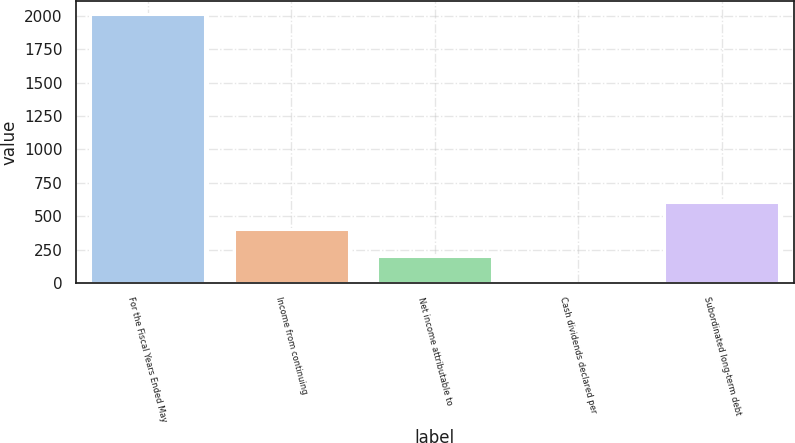<chart> <loc_0><loc_0><loc_500><loc_500><bar_chart><fcel>For the Fiscal Years Ended May<fcel>Income from continuing<fcel>Net income attributable to<fcel>Cash dividends declared per<fcel>Subordinated long-term debt<nl><fcel>2010<fcel>402.63<fcel>201.71<fcel>0.79<fcel>603.55<nl></chart> 